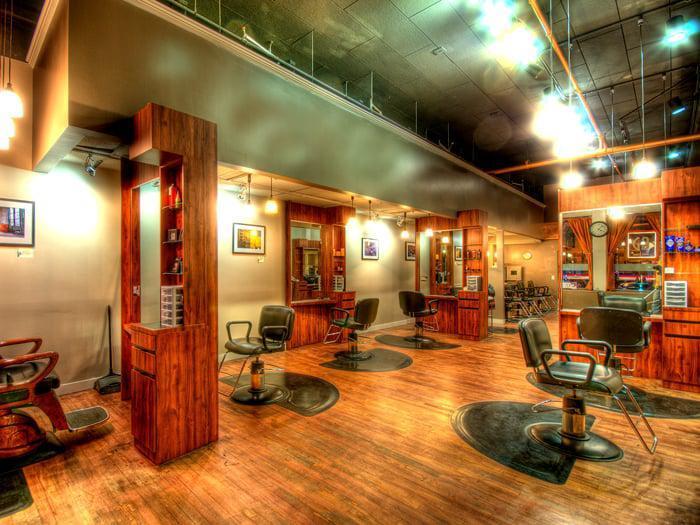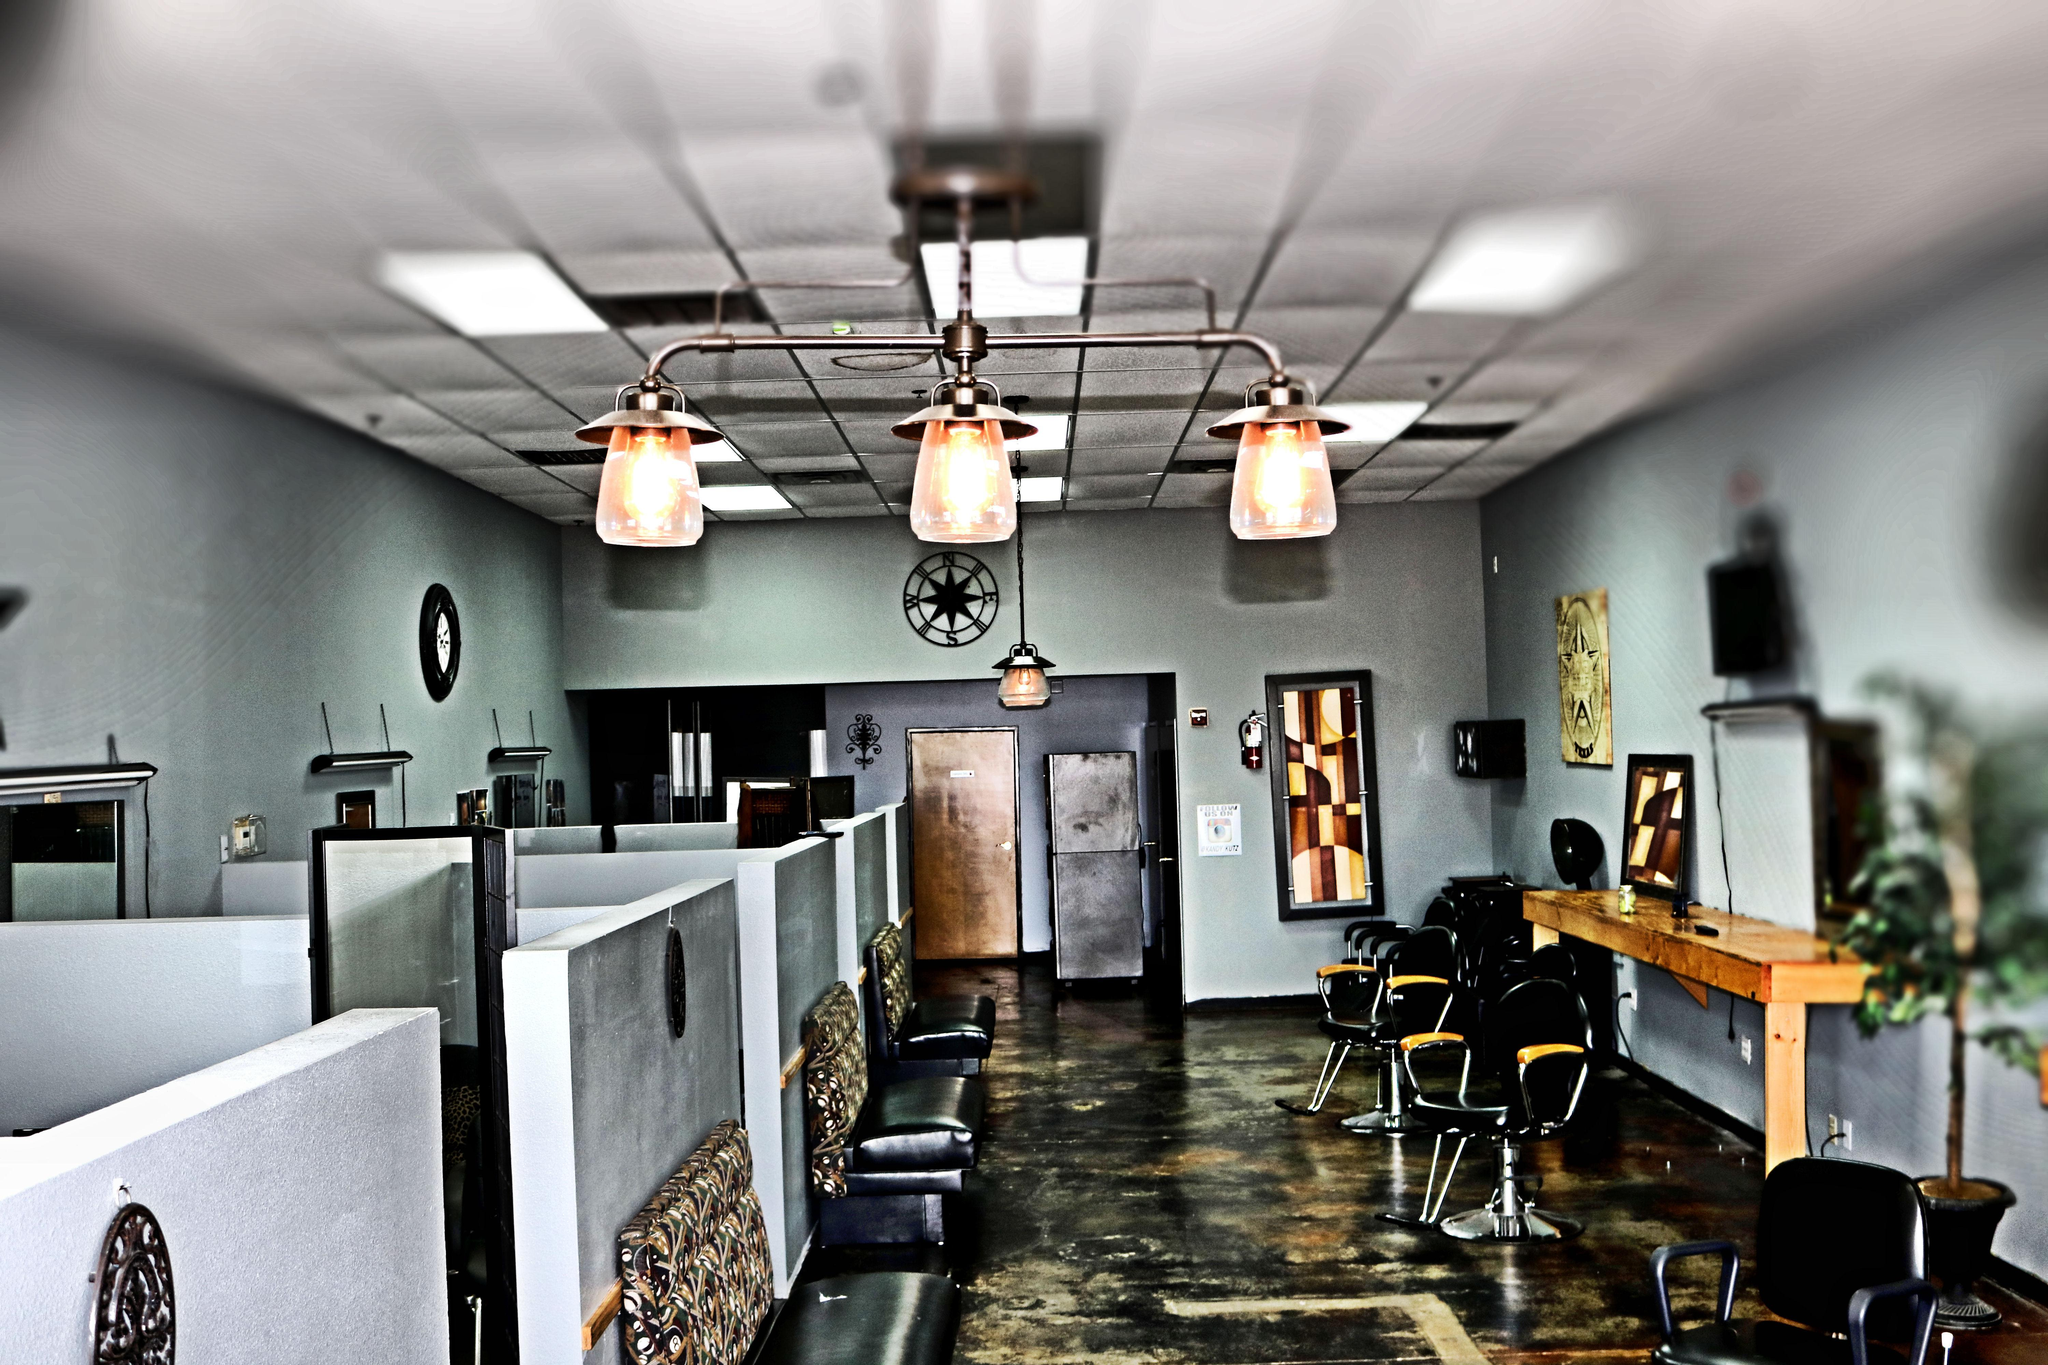The first image is the image on the left, the second image is the image on the right. Analyze the images presented: Is the assertion "A long oblong counter with a peaked top is in the center of the salon, flanked by barber chairs, in one image." valid? Answer yes or no. No. 